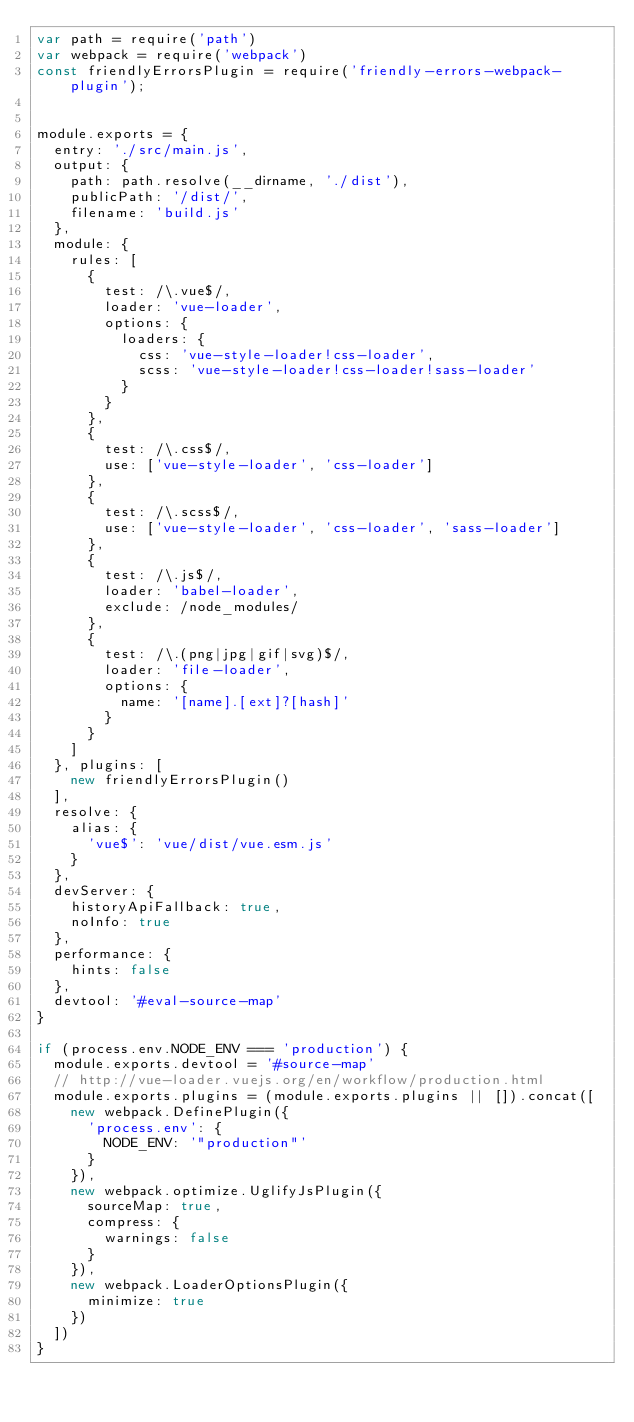<code> <loc_0><loc_0><loc_500><loc_500><_JavaScript_>var path = require('path')
var webpack = require('webpack')
const friendlyErrorsPlugin = require('friendly-errors-webpack-plugin');


module.exports = {
	entry: './src/main.js',
	output: {
		path: path.resolve(__dirname, './dist'),
		publicPath: '/dist/',
		filename: 'build.js'
	},
	module: {
		rules: [
			{
				test: /\.vue$/,
				loader: 'vue-loader',
				options: {
					loaders: {
						css: 'vue-style-loader!css-loader',
						scss: 'vue-style-loader!css-loader!sass-loader'
					}
				}
			},
			{
				test: /\.css$/,
				use: ['vue-style-loader', 'css-loader']
			},
			{
				test: /\.scss$/,
				use: ['vue-style-loader', 'css-loader', 'sass-loader']
			},
			{
				test: /\.js$/,
				loader: 'babel-loader',
				exclude: /node_modules/
			},
			{
				test: /\.(png|jpg|gif|svg)$/,
				loader: 'file-loader',
				options: {
					name: '[name].[ext]?[hash]'
				}
			}
		]
	}, plugins: [
		new friendlyErrorsPlugin()
	],
	resolve: {
		alias: {
			'vue$': 'vue/dist/vue.esm.js'
		}
	},
	devServer: {
		historyApiFallback: true,
		noInfo: true
	},
	performance: {
		hints: false
	},
	devtool: '#eval-source-map'
}

if (process.env.NODE_ENV === 'production') {
	module.exports.devtool = '#source-map'
	// http://vue-loader.vuejs.org/en/workflow/production.html
	module.exports.plugins = (module.exports.plugins || []).concat([
		new webpack.DefinePlugin({
			'process.env': {
				NODE_ENV: '"production"'
			}
		}),
		new webpack.optimize.UglifyJsPlugin({
			sourceMap: true,
			compress: {
				warnings: false
			}
		}),
		new webpack.LoaderOptionsPlugin({
			minimize: true
		})
	])
}
</code> 